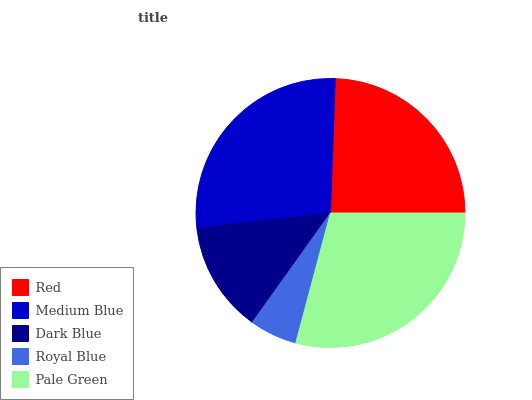Is Royal Blue the minimum?
Answer yes or no. Yes. Is Pale Green the maximum?
Answer yes or no. Yes. Is Medium Blue the minimum?
Answer yes or no. No. Is Medium Blue the maximum?
Answer yes or no. No. Is Medium Blue greater than Red?
Answer yes or no. Yes. Is Red less than Medium Blue?
Answer yes or no. Yes. Is Red greater than Medium Blue?
Answer yes or no. No. Is Medium Blue less than Red?
Answer yes or no. No. Is Red the high median?
Answer yes or no. Yes. Is Red the low median?
Answer yes or no. Yes. Is Royal Blue the high median?
Answer yes or no. No. Is Royal Blue the low median?
Answer yes or no. No. 